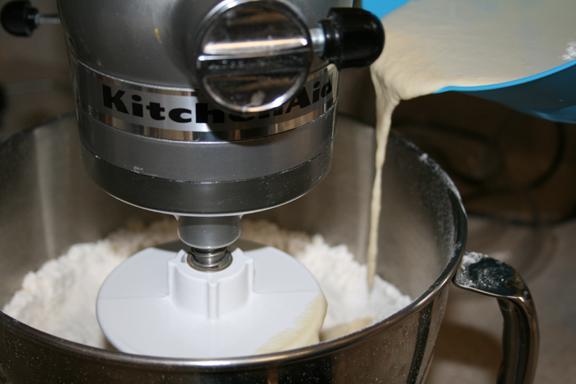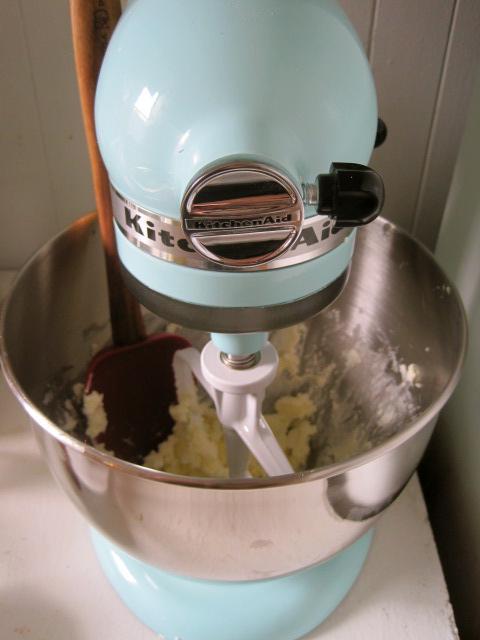The first image is the image on the left, the second image is the image on the right. Analyze the images presented: Is the assertion "Each image shows a beater in a bowl of dough, but one image features a solid disk-shaped white beater blade and the other features a bar-shaped white blade." valid? Answer yes or no. Yes. 